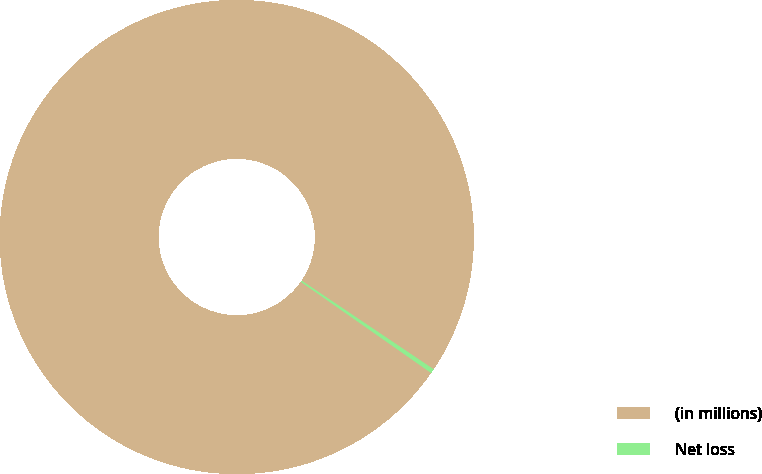<chart> <loc_0><loc_0><loc_500><loc_500><pie_chart><fcel>(in millions)<fcel>Net loss<nl><fcel>99.7%<fcel>0.3%<nl></chart> 